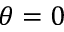Convert formula to latex. <formula><loc_0><loc_0><loc_500><loc_500>\theta = 0</formula> 